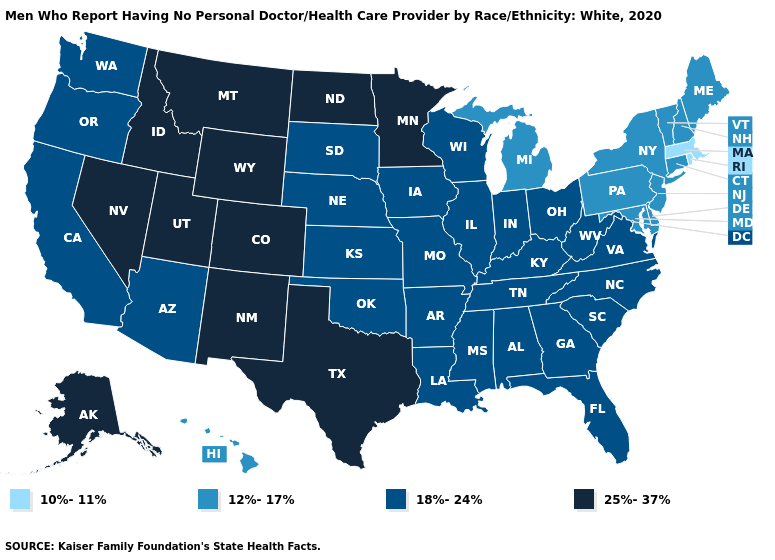What is the value of South Carolina?
Write a very short answer. 18%-24%. What is the lowest value in the South?
Quick response, please. 12%-17%. What is the highest value in the West ?
Write a very short answer. 25%-37%. What is the value of California?
Concise answer only. 18%-24%. Name the states that have a value in the range 18%-24%?
Write a very short answer. Alabama, Arizona, Arkansas, California, Florida, Georgia, Illinois, Indiana, Iowa, Kansas, Kentucky, Louisiana, Mississippi, Missouri, Nebraska, North Carolina, Ohio, Oklahoma, Oregon, South Carolina, South Dakota, Tennessee, Virginia, Washington, West Virginia, Wisconsin. Among the states that border Massachusetts , does Rhode Island have the highest value?
Quick response, please. No. Does the first symbol in the legend represent the smallest category?
Write a very short answer. Yes. Does Arizona have the highest value in the West?
Be succinct. No. What is the lowest value in states that border Alabama?
Write a very short answer. 18%-24%. Name the states that have a value in the range 10%-11%?
Be succinct. Massachusetts, Rhode Island. What is the value of Utah?
Short answer required. 25%-37%. Does New York have a lower value than Hawaii?
Answer briefly. No. What is the value of Virginia?
Answer briefly. 18%-24%. What is the highest value in states that border Iowa?
Give a very brief answer. 25%-37%. What is the lowest value in the West?
Be succinct. 12%-17%. 